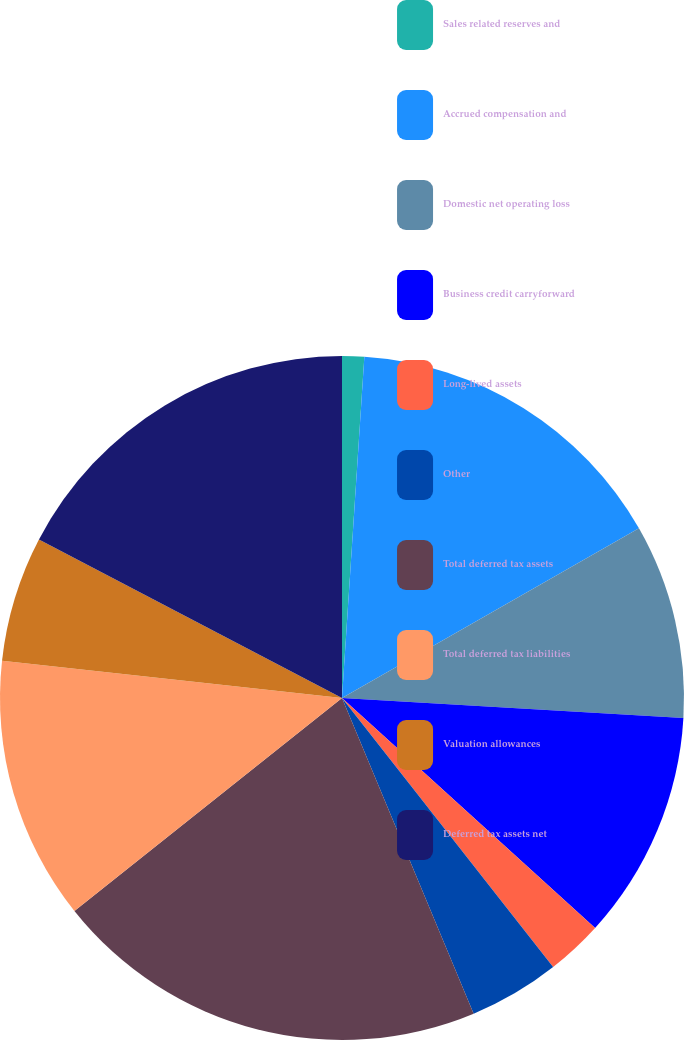Convert chart. <chart><loc_0><loc_0><loc_500><loc_500><pie_chart><fcel>Sales related reserves and<fcel>Accrued compensation and<fcel>Domestic net operating loss<fcel>Business credit carryforward<fcel>Long-lived assets<fcel>Other<fcel>Total deferred tax assets<fcel>Total deferred tax liabilities<fcel>Valuation allowances<fcel>Deferred tax assets net<nl><fcel>1.04%<fcel>15.7%<fcel>9.19%<fcel>10.81%<fcel>2.67%<fcel>4.3%<fcel>20.59%<fcel>12.44%<fcel>5.93%<fcel>17.33%<nl></chart> 